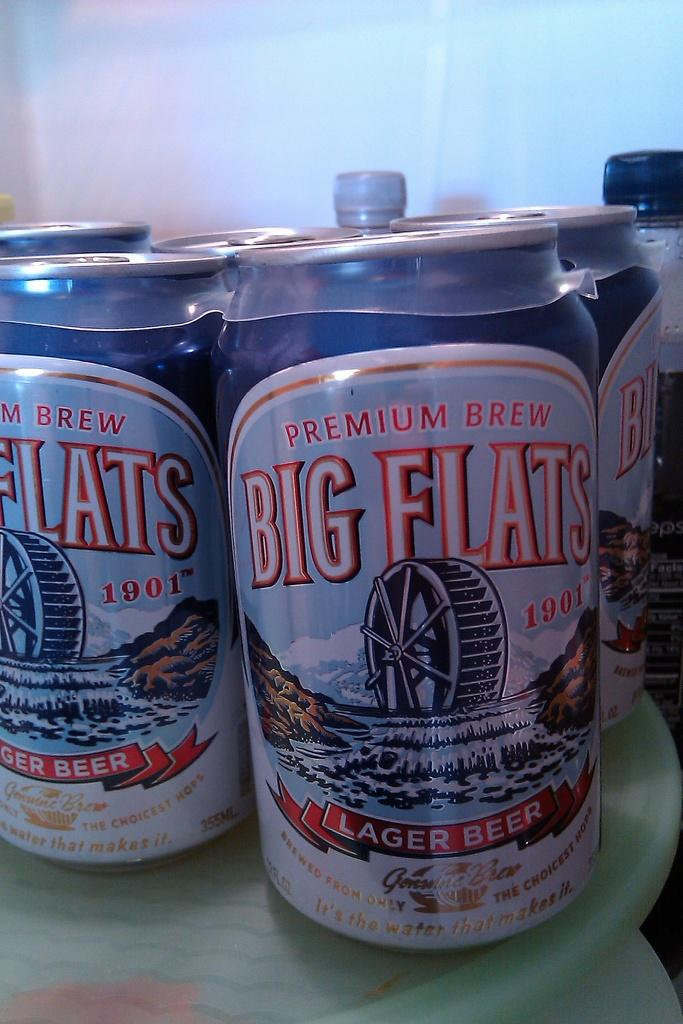Provide a one-sentence caption for the provided image. Several cans of Big Flats premium lager beer/. 